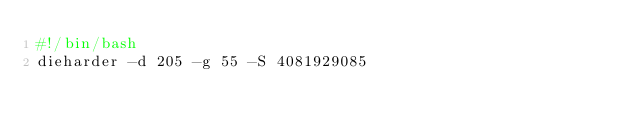<code> <loc_0><loc_0><loc_500><loc_500><_Bash_>#!/bin/bash
dieharder -d 205 -g 55 -S 4081929085
</code> 